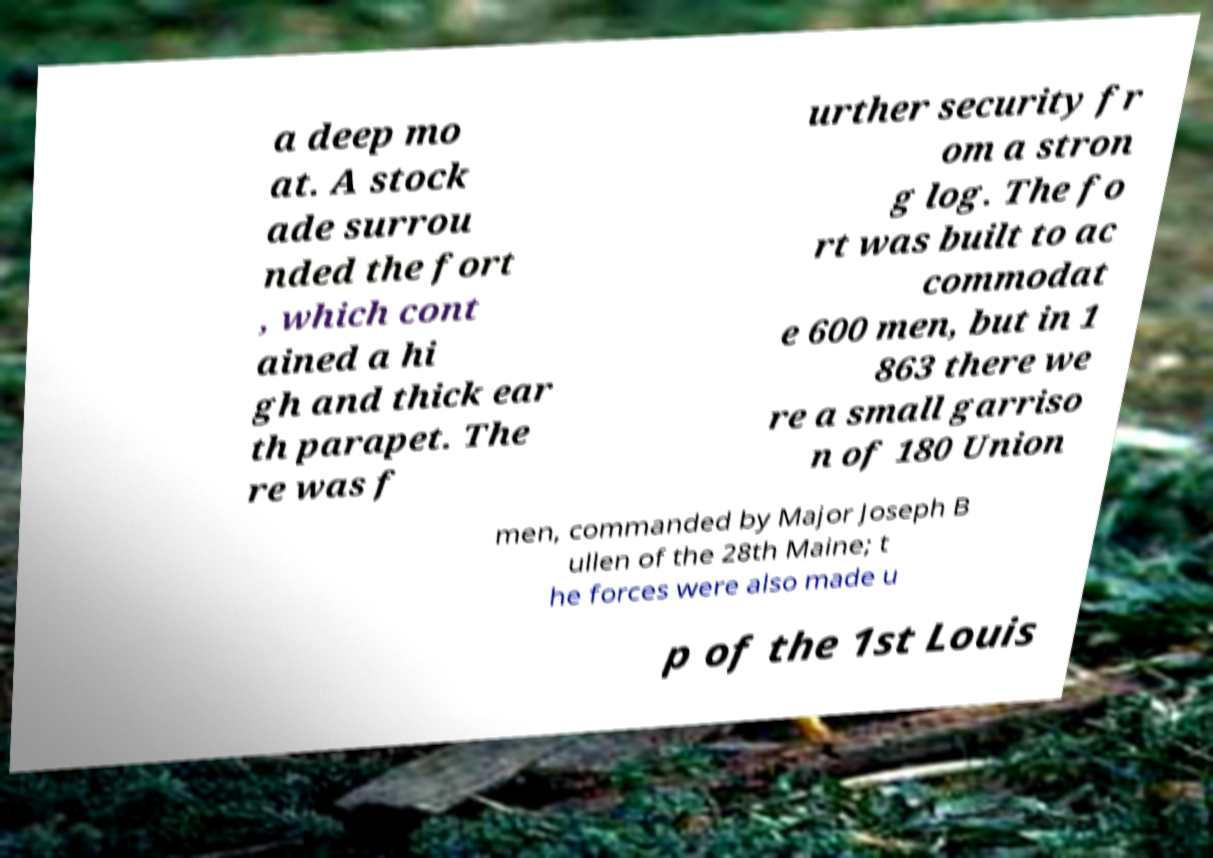Please identify and transcribe the text found in this image. a deep mo at. A stock ade surrou nded the fort , which cont ained a hi gh and thick ear th parapet. The re was f urther security fr om a stron g log. The fo rt was built to ac commodat e 600 men, but in 1 863 there we re a small garriso n of 180 Union men, commanded by Major Joseph B ullen of the 28th Maine; t he forces were also made u p of the 1st Louis 